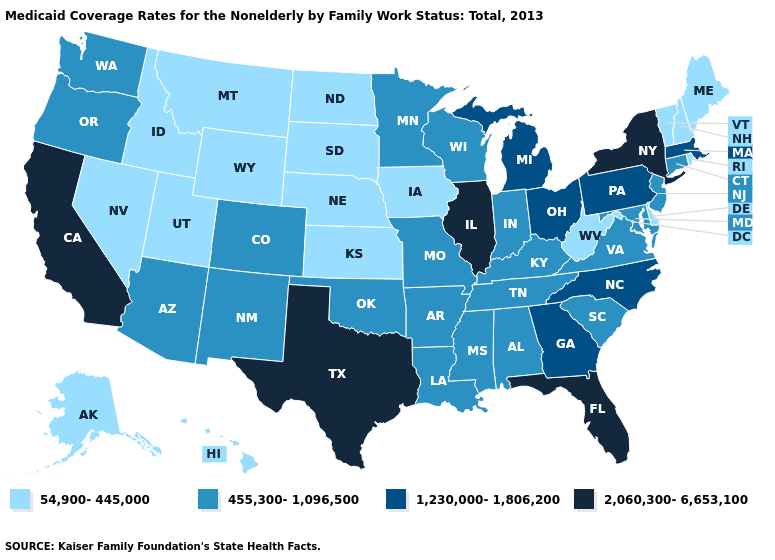How many symbols are there in the legend?
Keep it brief. 4. Among the states that border Nebraska , does Missouri have the lowest value?
Concise answer only. No. Does Connecticut have the same value as Virginia?
Keep it brief. Yes. What is the highest value in the West ?
Give a very brief answer. 2,060,300-6,653,100. Among the states that border New Jersey , which have the highest value?
Concise answer only. New York. Which states have the highest value in the USA?
Give a very brief answer. California, Florida, Illinois, New York, Texas. Does South Carolina have a higher value than North Carolina?
Concise answer only. No. Does Delaware have the highest value in the South?
Be succinct. No. What is the value of New Jersey?
Write a very short answer. 455,300-1,096,500. Among the states that border Oklahoma , does Kansas have the lowest value?
Give a very brief answer. Yes. What is the value of Missouri?
Short answer required. 455,300-1,096,500. Does Pennsylvania have the lowest value in the Northeast?
Answer briefly. No. What is the highest value in the South ?
Short answer required. 2,060,300-6,653,100. Does the map have missing data?
Give a very brief answer. No. 